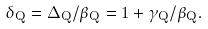Convert formula to latex. <formula><loc_0><loc_0><loc_500><loc_500>\delta _ { Q } = \Delta _ { Q } / \beta _ { Q } = 1 + \gamma _ { Q } / \beta _ { Q } .</formula> 